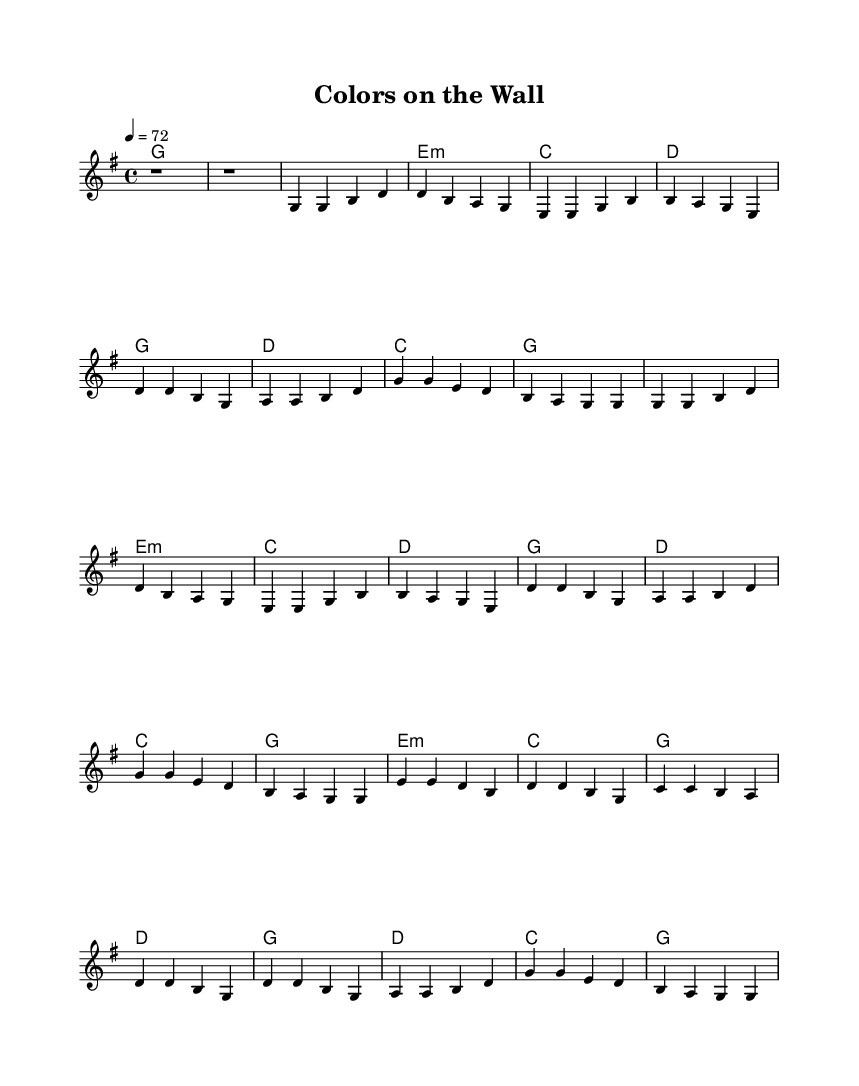What is the key signature of this music? The key signature is G major, which has one sharp (F#). This is determined by the presence of the sharp in the header or the absence of any flat symbols.
Answer: G major What is the time signature of this music? The time signature is 4/4, indicating there are four beats in each measure and a quarter note receives one beat. This is evident in the time signature notation at the beginning of the score.
Answer: 4/4 What is the tempo marking given in the music? The tempo marking is 72 beats per minute, as written in the tempo indication portion of the score. This tells us how fast the piece should be played.
Answer: 72 How many verses are there in this ballad? There are two verses present in the structure of the music, as indicated by the repeated section that follows the same melody and chord progression.
Answer: 2 What is the structure pattern of the song? The structure of the song follows a pattern of Verse 1, Chorus, Verse 2, Chorus, Bridge, and Chorus, exhibiting a common format found in country ballads. This can be identified by the labeling of sections in the score.
Answer: Verse, Chorus, Bridge What is the tonic chord of the piece? The tonic chord is G major, as it is the first chord listed in the chord progression and serves as the home chord of the piece. The overall harmony supports this as the primary chord around which the music revolves.
Answer: G major What musical genre does this piece represent? This piece represents the country music genre, which is evident through its lyrical themes and musical composition typical of modern country ballads focusing on storytelling and emotional expression.
Answer: Country 